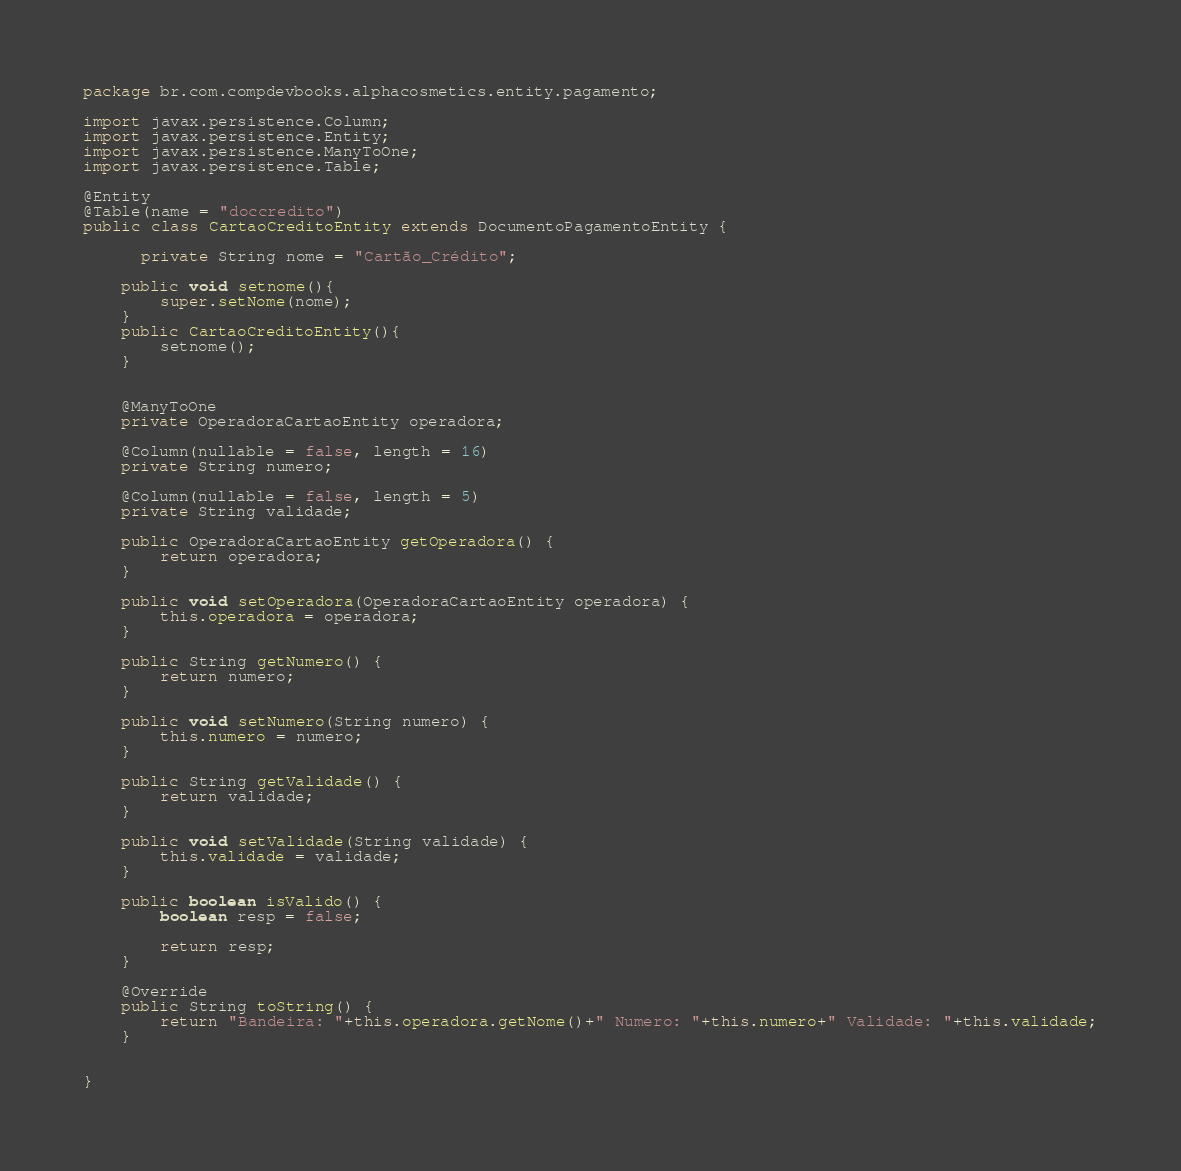<code> <loc_0><loc_0><loc_500><loc_500><_Java_>package br.com.compdevbooks.alphacosmetics.entity.pagamento;

import javax.persistence.Column;
import javax.persistence.Entity;
import javax.persistence.ManyToOne;
import javax.persistence.Table;

@Entity
@Table(name = "doccredito")
public class CartaoCreditoEntity extends DocumentoPagamentoEntity {
    
      private String nome = "Cartão_Crédito";
    
    public void setnome(){
        super.setNome(nome);
    }
    public CartaoCreditoEntity(){
        setnome();
    }
    
    
    @ManyToOne
    private OperadoraCartaoEntity operadora;
    
    @Column(nullable = false, length = 16)
    private String numero;
    
    @Column(nullable = false, length = 5)
    private String validade;

    public OperadoraCartaoEntity getOperadora() {
        return operadora;
    }

    public void setOperadora(OperadoraCartaoEntity operadora) {
        this.operadora = operadora;
    }

    public String getNumero() {
        return numero;
    }

    public void setNumero(String numero) {
        this.numero = numero;
    }

    public String getValidade() {
        return validade;
    }

    public void setValidade(String validade) {
        this.validade = validade;
    }

    public boolean isValido() {
        boolean resp = false;

        return resp;
    }

    @Override
    public String toString() {
        return "Bandeira: "+this.operadora.getNome()+" Numero: "+this.numero+" Validade: "+this.validade;
    }
    
    
}
</code> 